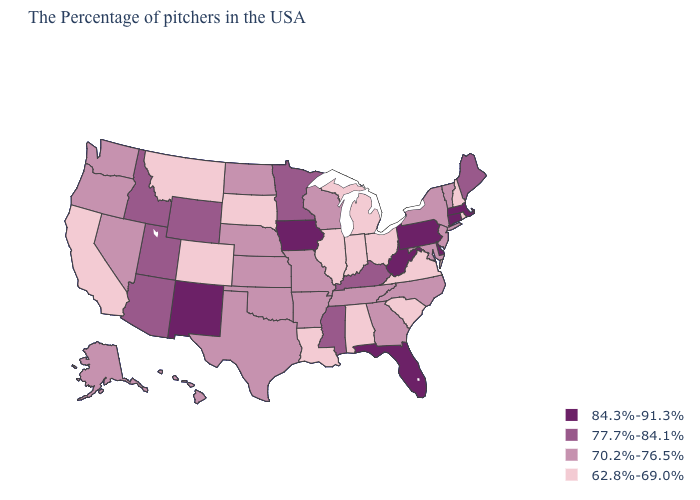What is the highest value in states that border Idaho?
Quick response, please. 77.7%-84.1%. Among the states that border Utah , which have the highest value?
Be succinct. New Mexico. What is the value of Rhode Island?
Write a very short answer. 62.8%-69.0%. What is the highest value in the South ?
Write a very short answer. 84.3%-91.3%. Name the states that have a value in the range 62.8%-69.0%?
Short answer required. Rhode Island, New Hampshire, Virginia, South Carolina, Ohio, Michigan, Indiana, Alabama, Illinois, Louisiana, South Dakota, Colorado, Montana, California. Among the states that border Florida , does Georgia have the lowest value?
Short answer required. No. Does New Mexico have the highest value in the West?
Concise answer only. Yes. Does Alabama have the highest value in the USA?
Be succinct. No. Which states have the highest value in the USA?
Keep it brief. Massachusetts, Connecticut, Delaware, Pennsylvania, West Virginia, Florida, Iowa, New Mexico. Does Wisconsin have a lower value than Kansas?
Keep it brief. No. Name the states that have a value in the range 62.8%-69.0%?
Short answer required. Rhode Island, New Hampshire, Virginia, South Carolina, Ohio, Michigan, Indiana, Alabama, Illinois, Louisiana, South Dakota, Colorado, Montana, California. What is the value of Iowa?
Write a very short answer. 84.3%-91.3%. What is the value of Pennsylvania?
Be succinct. 84.3%-91.3%. 